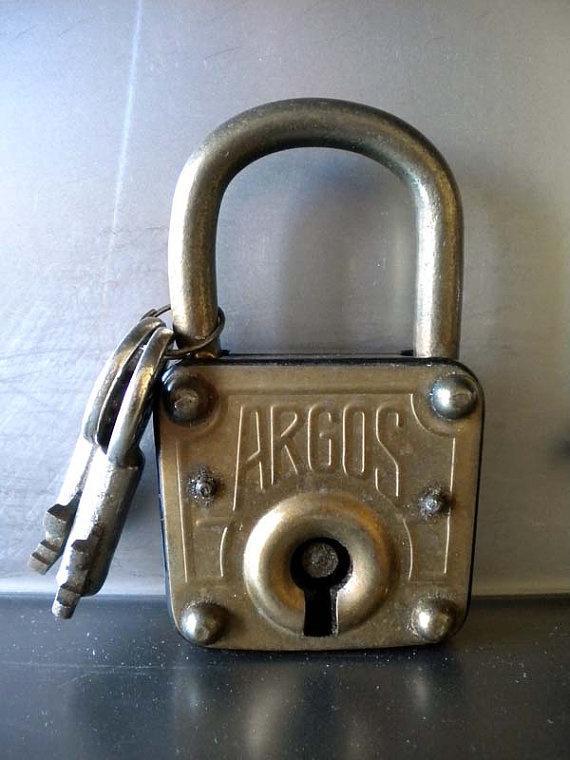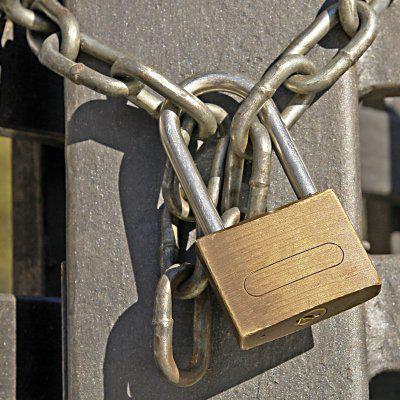The first image is the image on the left, the second image is the image on the right. Analyze the images presented: Is the assertion "Each image contains only non-square vintage locks and contains at least one key." valid? Answer yes or no. No. The first image is the image on the left, the second image is the image on the right. Analyze the images presented: Is the assertion "At least one key is lying beside a lock." valid? Answer yes or no. No. 